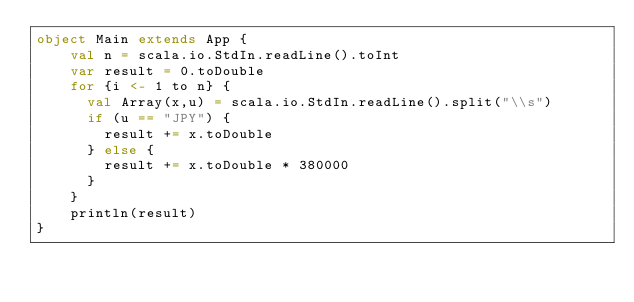<code> <loc_0><loc_0><loc_500><loc_500><_Scala_>object Main extends App {
    val n = scala.io.StdIn.readLine().toInt
    var result = 0.toDouble
    for {i <- 1 to n} {
      val Array(x,u) = scala.io.StdIn.readLine().split("\\s")
      if (u == "JPY") {
        result += x.toDouble
      } else {
        result += x.toDouble * 380000
      }
    }
    println(result)
}</code> 